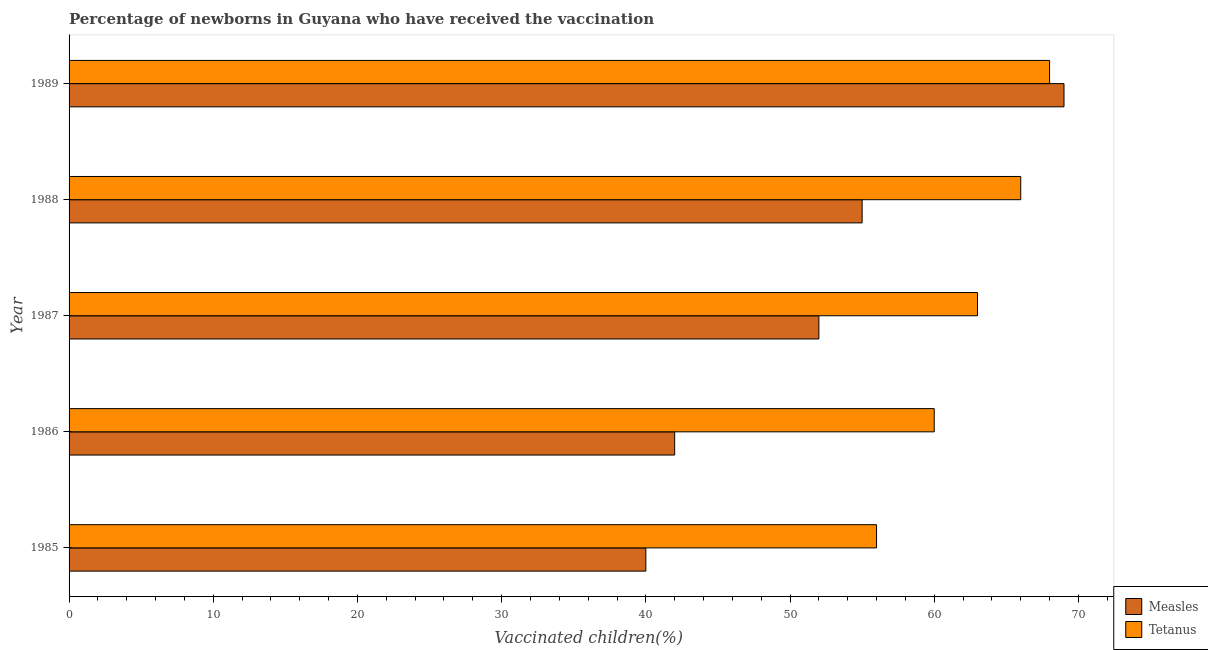How many different coloured bars are there?
Your answer should be compact. 2. How many groups of bars are there?
Your answer should be compact. 5. How many bars are there on the 5th tick from the bottom?
Offer a terse response. 2. In how many cases, is the number of bars for a given year not equal to the number of legend labels?
Offer a very short reply. 0. What is the percentage of newborns who received vaccination for tetanus in 1986?
Ensure brevity in your answer.  60. Across all years, what is the maximum percentage of newborns who received vaccination for tetanus?
Provide a succinct answer. 68. Across all years, what is the minimum percentage of newborns who received vaccination for measles?
Your response must be concise. 40. In which year was the percentage of newborns who received vaccination for measles maximum?
Offer a terse response. 1989. In which year was the percentage of newborns who received vaccination for tetanus minimum?
Give a very brief answer. 1985. What is the total percentage of newborns who received vaccination for tetanus in the graph?
Provide a succinct answer. 313. What is the difference between the percentage of newborns who received vaccination for measles in 1985 and that in 1989?
Make the answer very short. -29. What is the difference between the percentage of newborns who received vaccination for measles in 1985 and the percentage of newborns who received vaccination for tetanus in 1988?
Give a very brief answer. -26. What is the average percentage of newborns who received vaccination for tetanus per year?
Make the answer very short. 62.6. In the year 1988, what is the difference between the percentage of newborns who received vaccination for tetanus and percentage of newborns who received vaccination for measles?
Your answer should be very brief. 11. Is the difference between the percentage of newborns who received vaccination for measles in 1985 and 1988 greater than the difference between the percentage of newborns who received vaccination for tetanus in 1985 and 1988?
Your response must be concise. No. What is the difference between the highest and the second highest percentage of newborns who received vaccination for measles?
Your answer should be compact. 14. What is the difference between the highest and the lowest percentage of newborns who received vaccination for tetanus?
Ensure brevity in your answer.  12. In how many years, is the percentage of newborns who received vaccination for tetanus greater than the average percentage of newborns who received vaccination for tetanus taken over all years?
Keep it short and to the point. 3. Is the sum of the percentage of newborns who received vaccination for measles in 1985 and 1989 greater than the maximum percentage of newborns who received vaccination for tetanus across all years?
Keep it short and to the point. Yes. What does the 2nd bar from the top in 1988 represents?
Keep it short and to the point. Measles. What does the 2nd bar from the bottom in 1986 represents?
Offer a terse response. Tetanus. How many bars are there?
Ensure brevity in your answer.  10. How many years are there in the graph?
Your answer should be very brief. 5. How are the legend labels stacked?
Offer a very short reply. Vertical. What is the title of the graph?
Give a very brief answer. Percentage of newborns in Guyana who have received the vaccination. Does "International Visitors" appear as one of the legend labels in the graph?
Offer a terse response. No. What is the label or title of the X-axis?
Make the answer very short. Vaccinated children(%)
. What is the label or title of the Y-axis?
Provide a short and direct response. Year. What is the Vaccinated children(%)
 of Measles in 1985?
Make the answer very short. 40. What is the Vaccinated children(%)
 in Tetanus in 1985?
Keep it short and to the point. 56. What is the Vaccinated children(%)
 in Tetanus in 1987?
Your answer should be very brief. 63. What is the Vaccinated children(%)
 in Measles in 1988?
Offer a terse response. 55. What is the Vaccinated children(%)
 of Measles in 1989?
Your answer should be very brief. 69. Across all years, what is the maximum Vaccinated children(%)
 in Tetanus?
Give a very brief answer. 68. What is the total Vaccinated children(%)
 in Measles in the graph?
Provide a succinct answer. 258. What is the total Vaccinated children(%)
 in Tetanus in the graph?
Your answer should be very brief. 313. What is the difference between the Vaccinated children(%)
 of Tetanus in 1985 and that in 1988?
Keep it short and to the point. -10. What is the difference between the Vaccinated children(%)
 of Measles in 1985 and that in 1989?
Your answer should be compact. -29. What is the difference between the Vaccinated children(%)
 of Tetanus in 1985 and that in 1989?
Your response must be concise. -12. What is the difference between the Vaccinated children(%)
 of Tetanus in 1987 and that in 1988?
Give a very brief answer. -3. What is the difference between the Vaccinated children(%)
 in Measles in 1987 and that in 1989?
Your answer should be very brief. -17. What is the difference between the Vaccinated children(%)
 in Tetanus in 1987 and that in 1989?
Offer a terse response. -5. What is the difference between the Vaccinated children(%)
 in Measles in 1988 and that in 1989?
Provide a short and direct response. -14. What is the difference between the Vaccinated children(%)
 of Tetanus in 1988 and that in 1989?
Keep it short and to the point. -2. What is the difference between the Vaccinated children(%)
 in Measles in 1985 and the Vaccinated children(%)
 in Tetanus in 1986?
Offer a very short reply. -20. What is the difference between the Vaccinated children(%)
 of Measles in 1985 and the Vaccinated children(%)
 of Tetanus in 1987?
Offer a very short reply. -23. What is the difference between the Vaccinated children(%)
 of Measles in 1985 and the Vaccinated children(%)
 of Tetanus in 1989?
Provide a succinct answer. -28. What is the difference between the Vaccinated children(%)
 of Measles in 1986 and the Vaccinated children(%)
 of Tetanus in 1987?
Give a very brief answer. -21. What is the difference between the Vaccinated children(%)
 in Measles in 1986 and the Vaccinated children(%)
 in Tetanus in 1989?
Your answer should be very brief. -26. What is the average Vaccinated children(%)
 of Measles per year?
Your answer should be compact. 51.6. What is the average Vaccinated children(%)
 of Tetanus per year?
Provide a succinct answer. 62.6. In the year 1985, what is the difference between the Vaccinated children(%)
 in Measles and Vaccinated children(%)
 in Tetanus?
Keep it short and to the point. -16. In the year 1986, what is the difference between the Vaccinated children(%)
 of Measles and Vaccinated children(%)
 of Tetanus?
Offer a terse response. -18. In the year 1989, what is the difference between the Vaccinated children(%)
 in Measles and Vaccinated children(%)
 in Tetanus?
Offer a terse response. 1. What is the ratio of the Vaccinated children(%)
 in Measles in 1985 to that in 1986?
Offer a terse response. 0.95. What is the ratio of the Vaccinated children(%)
 in Tetanus in 1985 to that in 1986?
Provide a succinct answer. 0.93. What is the ratio of the Vaccinated children(%)
 in Measles in 1985 to that in 1987?
Provide a succinct answer. 0.77. What is the ratio of the Vaccinated children(%)
 in Tetanus in 1985 to that in 1987?
Give a very brief answer. 0.89. What is the ratio of the Vaccinated children(%)
 of Measles in 1985 to that in 1988?
Give a very brief answer. 0.73. What is the ratio of the Vaccinated children(%)
 in Tetanus in 1985 to that in 1988?
Provide a succinct answer. 0.85. What is the ratio of the Vaccinated children(%)
 of Measles in 1985 to that in 1989?
Provide a short and direct response. 0.58. What is the ratio of the Vaccinated children(%)
 of Tetanus in 1985 to that in 1989?
Your answer should be very brief. 0.82. What is the ratio of the Vaccinated children(%)
 in Measles in 1986 to that in 1987?
Ensure brevity in your answer.  0.81. What is the ratio of the Vaccinated children(%)
 in Tetanus in 1986 to that in 1987?
Make the answer very short. 0.95. What is the ratio of the Vaccinated children(%)
 of Measles in 1986 to that in 1988?
Offer a terse response. 0.76. What is the ratio of the Vaccinated children(%)
 in Measles in 1986 to that in 1989?
Provide a short and direct response. 0.61. What is the ratio of the Vaccinated children(%)
 of Tetanus in 1986 to that in 1989?
Your response must be concise. 0.88. What is the ratio of the Vaccinated children(%)
 of Measles in 1987 to that in 1988?
Your answer should be compact. 0.95. What is the ratio of the Vaccinated children(%)
 of Tetanus in 1987 to that in 1988?
Keep it short and to the point. 0.95. What is the ratio of the Vaccinated children(%)
 in Measles in 1987 to that in 1989?
Ensure brevity in your answer.  0.75. What is the ratio of the Vaccinated children(%)
 of Tetanus in 1987 to that in 1989?
Provide a succinct answer. 0.93. What is the ratio of the Vaccinated children(%)
 in Measles in 1988 to that in 1989?
Your answer should be very brief. 0.8. What is the ratio of the Vaccinated children(%)
 of Tetanus in 1988 to that in 1989?
Provide a short and direct response. 0.97. 